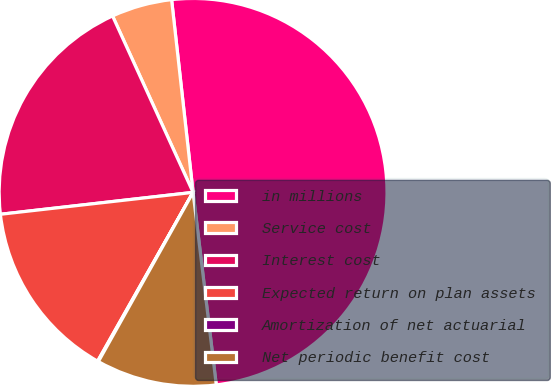Convert chart to OTSL. <chart><loc_0><loc_0><loc_500><loc_500><pie_chart><fcel>in millions<fcel>Service cost<fcel>Interest cost<fcel>Expected return on plan assets<fcel>Amortization of net actuarial<fcel>Net periodic benefit cost<nl><fcel>49.87%<fcel>5.05%<fcel>19.99%<fcel>15.01%<fcel>0.07%<fcel>10.03%<nl></chart> 